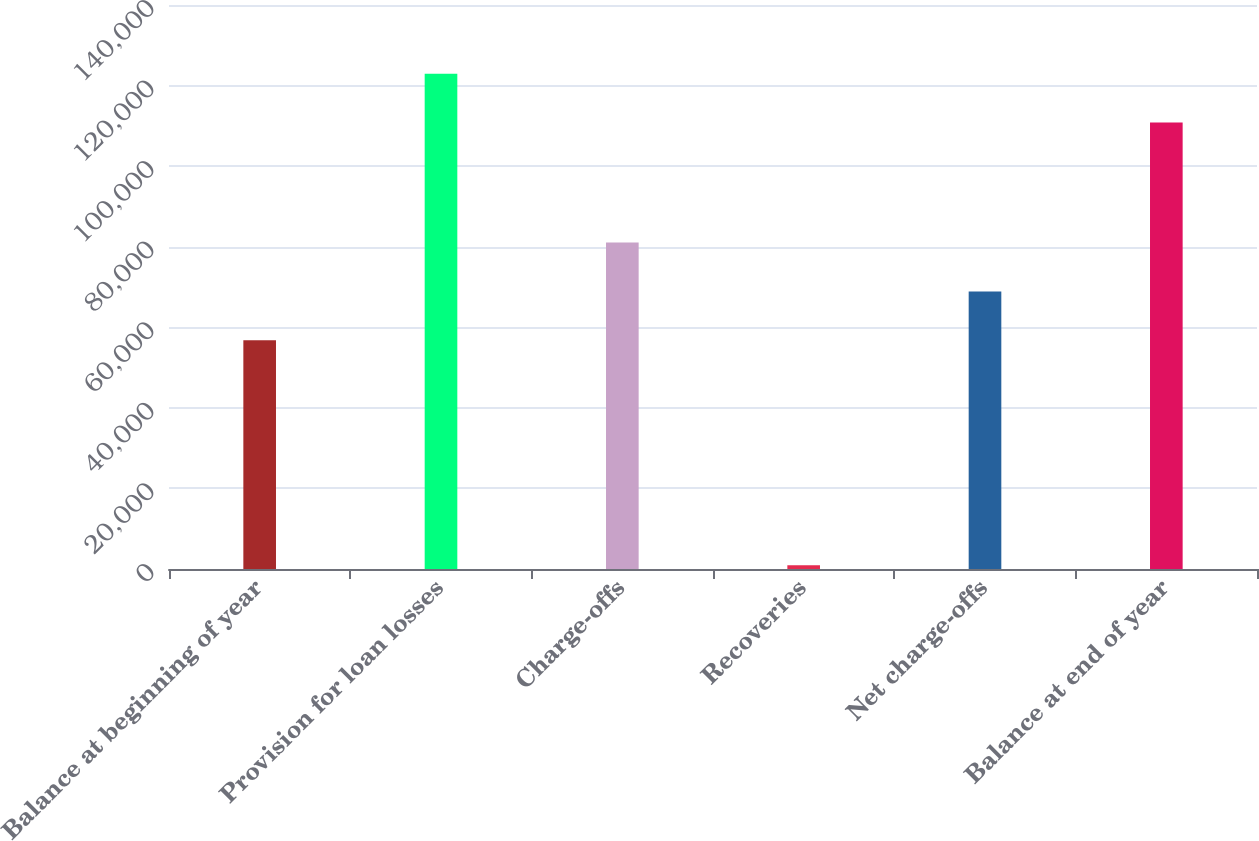Convert chart to OTSL. <chart><loc_0><loc_0><loc_500><loc_500><bar_chart><fcel>Balance at beginning of year<fcel>Provision for loan losses<fcel>Charge-offs<fcel>Recoveries<fcel>Net charge-offs<fcel>Balance at end of year<nl><fcel>56774<fcel>122936<fcel>81019.4<fcel>946<fcel>68896.7<fcel>110813<nl></chart> 